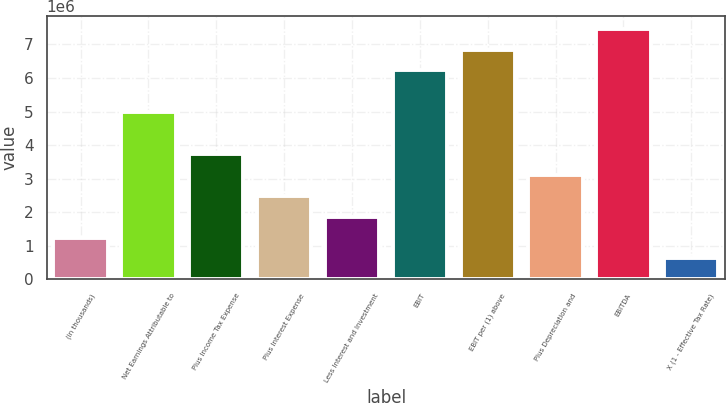Convert chart. <chart><loc_0><loc_0><loc_500><loc_500><bar_chart><fcel>(in thousands)<fcel>Net Earnings Attributable to<fcel>Plus Income Tax Expense<fcel>Plus Interest Expense<fcel>Less Interest and Investment<fcel>EBIT<fcel>EBIT per (1) above<fcel>Plus Depreciation and<fcel>EBITDA<fcel>X (1 - Effective Tax Rate)<nl><fcel>1.24514e+06<fcel>4.98052e+06<fcel>3.7354e+06<fcel>2.49027e+06<fcel>1.86771e+06<fcel>6.22565e+06<fcel>6.84821e+06<fcel>3.11283e+06<fcel>7.47078e+06<fcel>622580<nl></chart> 